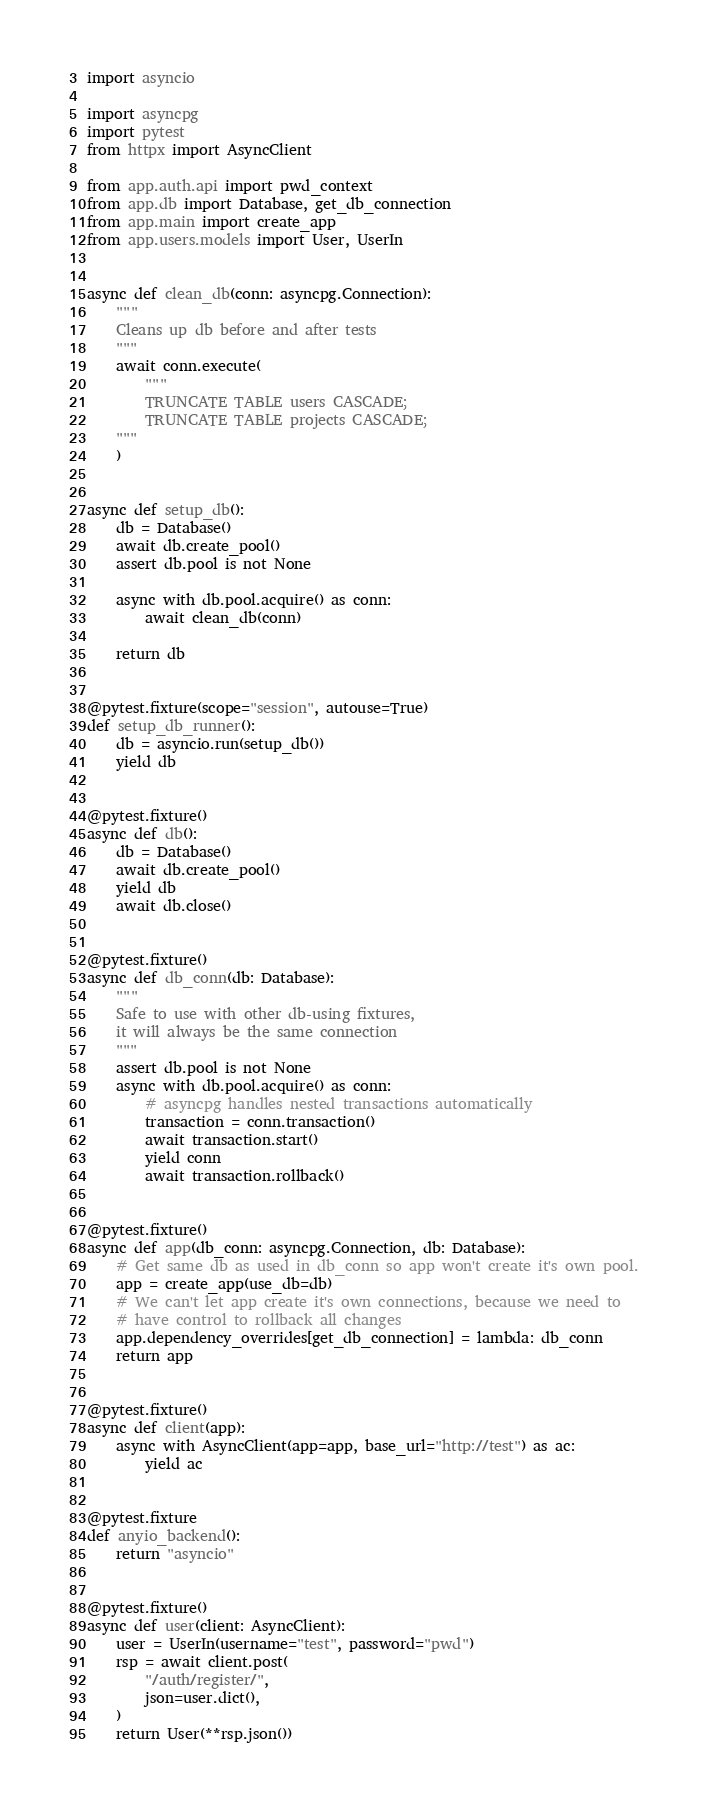<code> <loc_0><loc_0><loc_500><loc_500><_Python_>import asyncio

import asyncpg
import pytest
from httpx import AsyncClient

from app.auth.api import pwd_context
from app.db import Database, get_db_connection
from app.main import create_app
from app.users.models import User, UserIn


async def clean_db(conn: asyncpg.Connection):
    """
    Cleans up db before and after tests
    """
    await conn.execute(
        """
        TRUNCATE TABLE users CASCADE;
        TRUNCATE TABLE projects CASCADE;
    """
    )


async def setup_db():
    db = Database()
    await db.create_pool()
    assert db.pool is not None

    async with db.pool.acquire() as conn:
        await clean_db(conn)

    return db


@pytest.fixture(scope="session", autouse=True)
def setup_db_runner():
    db = asyncio.run(setup_db())
    yield db


@pytest.fixture()
async def db():
    db = Database()
    await db.create_pool()
    yield db
    await db.close()


@pytest.fixture()
async def db_conn(db: Database):
    """
    Safe to use with other db-using fixtures,
    it will always be the same connection
    """
    assert db.pool is not None
    async with db.pool.acquire() as conn:
        # asyncpg handles nested transactions automatically
        transaction = conn.transaction()
        await transaction.start()
        yield conn
        await transaction.rollback()


@pytest.fixture()
async def app(db_conn: asyncpg.Connection, db: Database):
    # Get same db as used in db_conn so app won't create it's own pool.
    app = create_app(use_db=db)
    # We can't let app create it's own connections, because we need to
    # have control to rollback all changes
    app.dependency_overrides[get_db_connection] = lambda: db_conn
    return app


@pytest.fixture()
async def client(app):
    async with AsyncClient(app=app, base_url="http://test") as ac:
        yield ac


@pytest.fixture
def anyio_backend():
    return "asyncio"


@pytest.fixture()
async def user(client: AsyncClient):
    user = UserIn(username="test", password="pwd")
    rsp = await client.post(
        "/auth/register/",
        json=user.dict(),
    )
    return User(**rsp.json())

</code> 